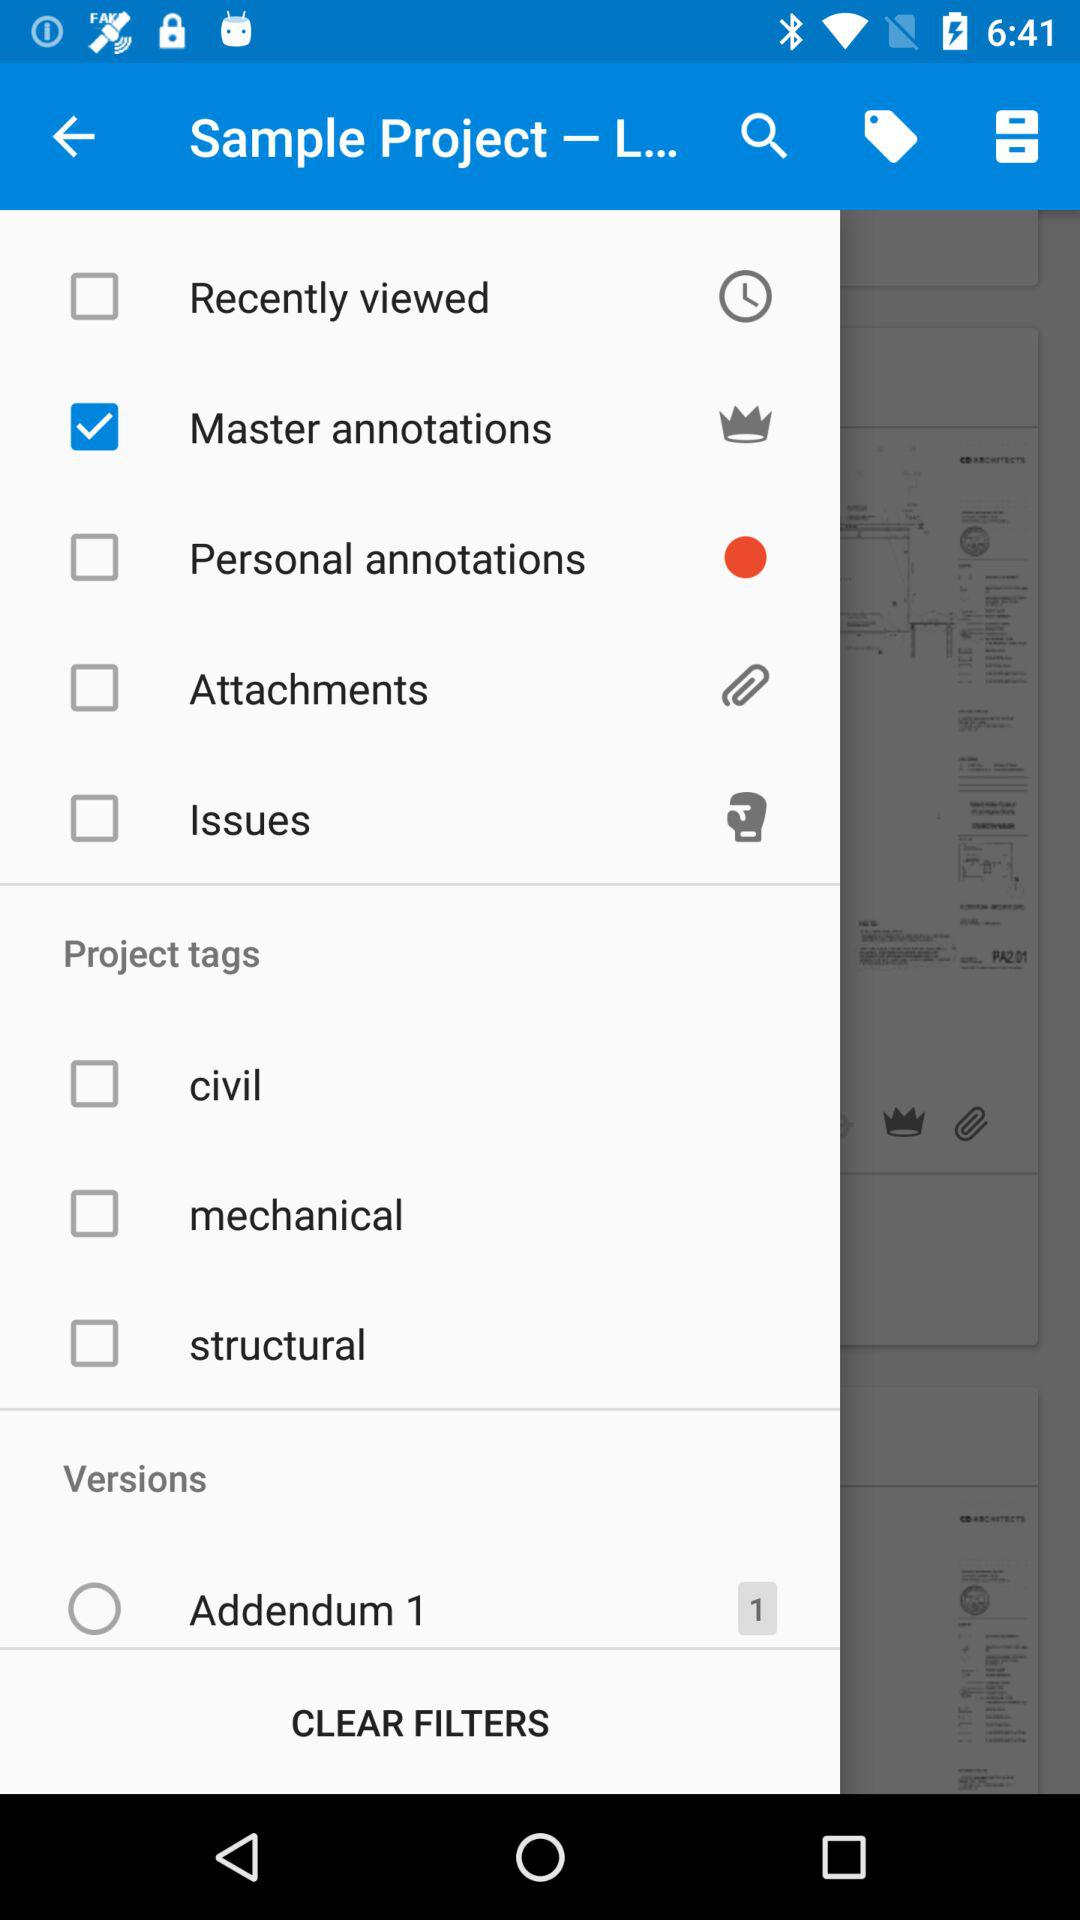Which category does "Addendum 1" fall under? "Addendum 1" falls under the "Versions" category. 